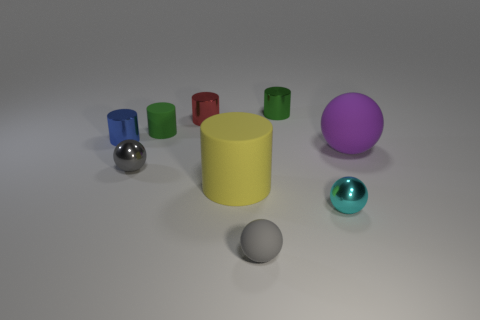Are there any patterns or themes among the shapes and colors of the objects? Yes, the objects represent an assortment of different geometric shapes and a range of colors, possibly suggesting a theme of diversity or variety in shape and color. The shapes include spheres, cylinders, and cubes, while the colors span the primary, secondary, and tertiary spectrum. 